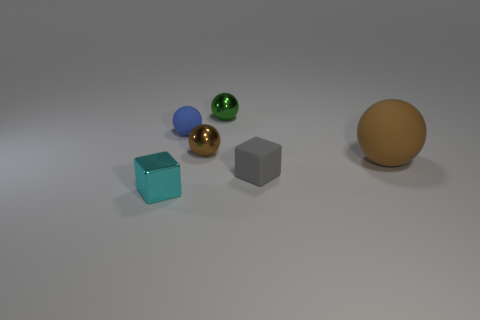What shape is the other object that is the same color as the big object? sphere 